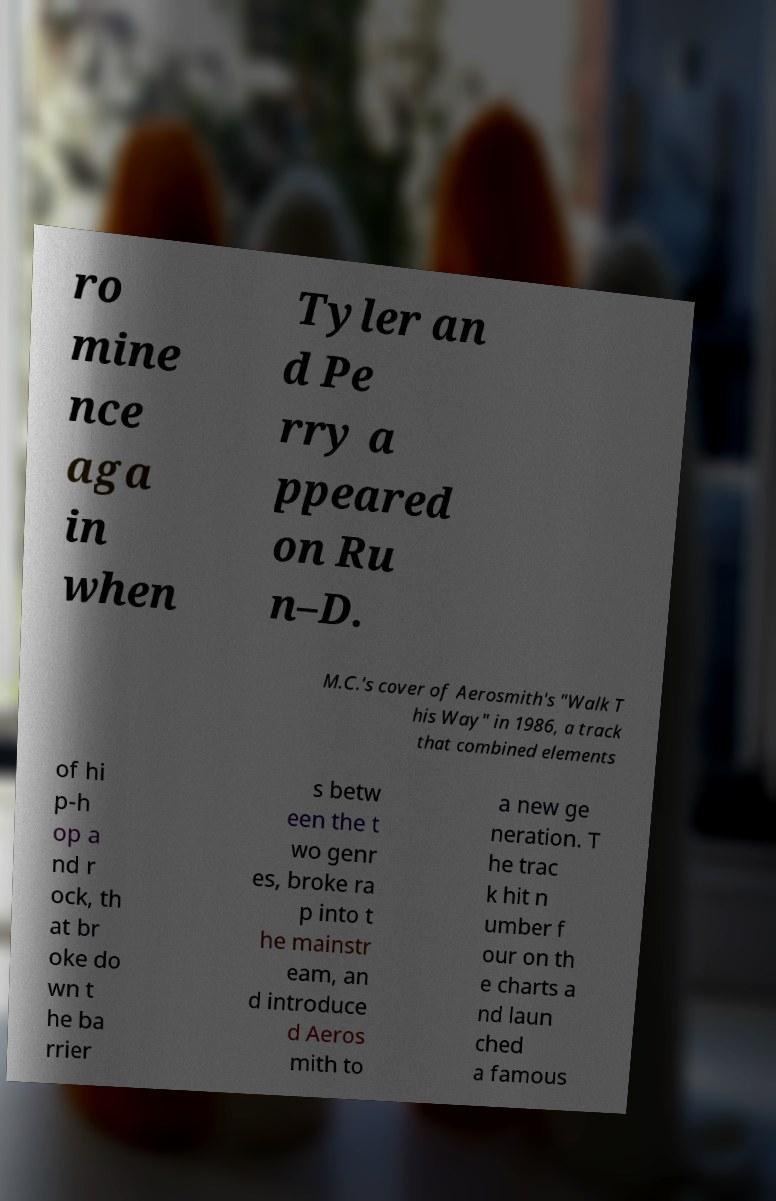For documentation purposes, I need the text within this image transcribed. Could you provide that? ro mine nce aga in when Tyler an d Pe rry a ppeared on Ru n–D. M.C.'s cover of Aerosmith's "Walk T his Way" in 1986, a track that combined elements of hi p-h op a nd r ock, th at br oke do wn t he ba rrier s betw een the t wo genr es, broke ra p into t he mainstr eam, an d introduce d Aeros mith to a new ge neration. T he trac k hit n umber f our on th e charts a nd laun ched a famous 